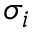Convert formula to latex. <formula><loc_0><loc_0><loc_500><loc_500>\sigma _ { i }</formula> 